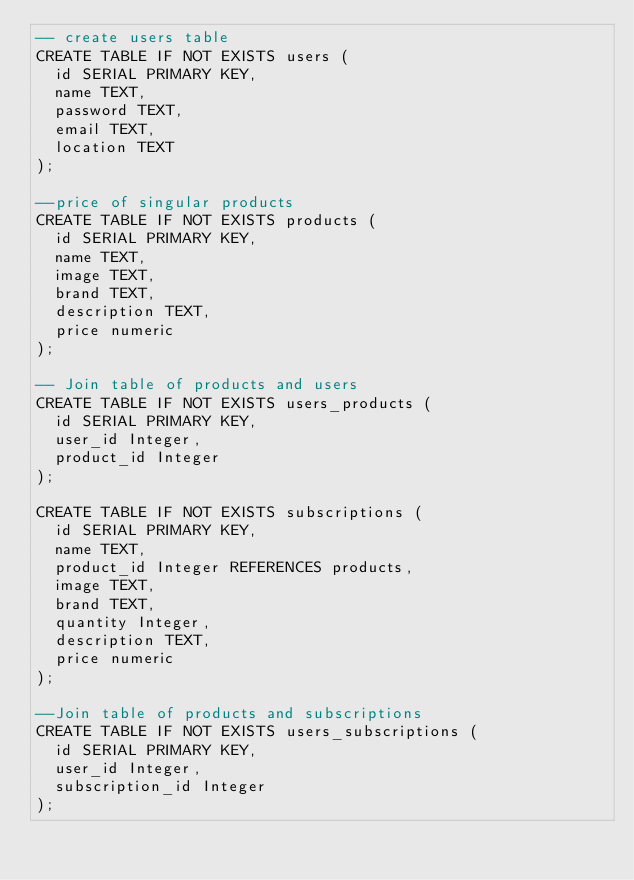Convert code to text. <code><loc_0><loc_0><loc_500><loc_500><_SQL_>-- create users table
CREATE TABLE IF NOT EXISTS users (
  id SERIAL PRIMARY KEY,
  name TEXT,
  password TEXT,
  email TEXT,
  location TEXT
);

--price of singular products
CREATE TABLE IF NOT EXISTS products (
  id SERIAL PRIMARY KEY,
  name TEXT,
  image TEXT,
  brand TEXT,
  description TEXT,
  price numeric
);

-- Join table of products and users
CREATE TABLE IF NOT EXISTS users_products (
  id SERIAL PRIMARY KEY,
  user_id Integer,
  product_id Integer
);

CREATE TABLE IF NOT EXISTS subscriptions (
  id SERIAL PRIMARY KEY,
  name TEXT,
  product_id Integer REFERENCES products,
  image TEXT,
  brand TEXT,
  quantity Integer,
  description TEXT,
  price numeric
);

--Join table of products and subscriptions
CREATE TABLE IF NOT EXISTS users_subscriptions (
  id SERIAL PRIMARY KEY,
  user_id Integer,
  subscription_id Integer
);</code> 